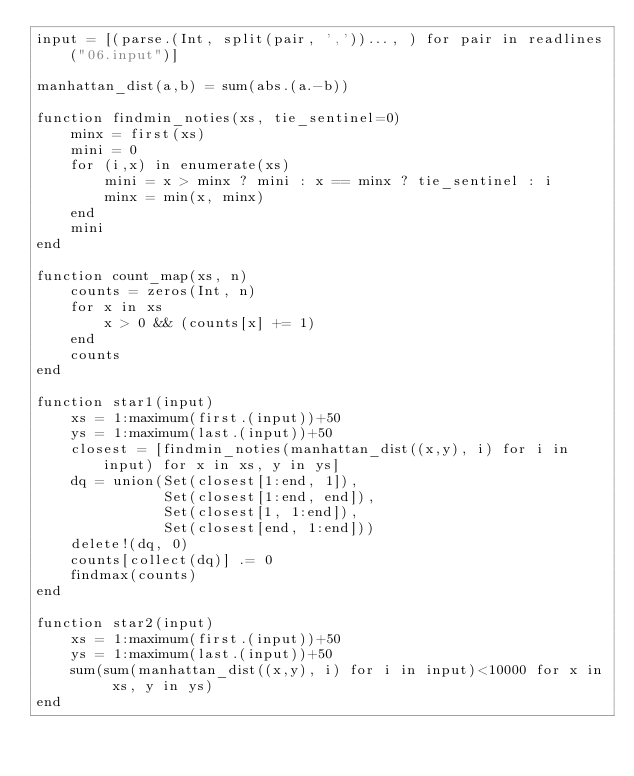<code> <loc_0><loc_0><loc_500><loc_500><_Julia_>input = [(parse.(Int, split(pair, ','))..., ) for pair in readlines("06.input")]

manhattan_dist(a,b) = sum(abs.(a.-b))

function findmin_noties(xs, tie_sentinel=0)
    minx = first(xs)
    mini = 0
    for (i,x) in enumerate(xs)
        mini = x > minx ? mini : x == minx ? tie_sentinel : i
        minx = min(x, minx)
    end
    mini
end

function count_map(xs, n)
    counts = zeros(Int, n)
    for x in xs
        x > 0 && (counts[x] += 1)
    end
    counts
end

function star1(input)
    xs = 1:maximum(first.(input))+50
    ys = 1:maximum(last.(input))+50
    closest = [findmin_noties(manhattan_dist((x,y), i) for i in input) for x in xs, y in ys]
    dq = union(Set(closest[1:end, 1]),
               Set(closest[1:end, end]),
               Set(closest[1, 1:end]),
               Set(closest[end, 1:end]))
    delete!(dq, 0)
    counts[collect(dq)] .= 0
    findmax(counts)
end

function star2(input)
    xs = 1:maximum(first.(input))+50
    ys = 1:maximum(last.(input))+50
    sum(sum(manhattan_dist((x,y), i) for i in input)<10000 for x in xs, y in ys)
end
</code> 